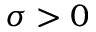Convert formula to latex. <formula><loc_0><loc_0><loc_500><loc_500>\sigma > 0</formula> 